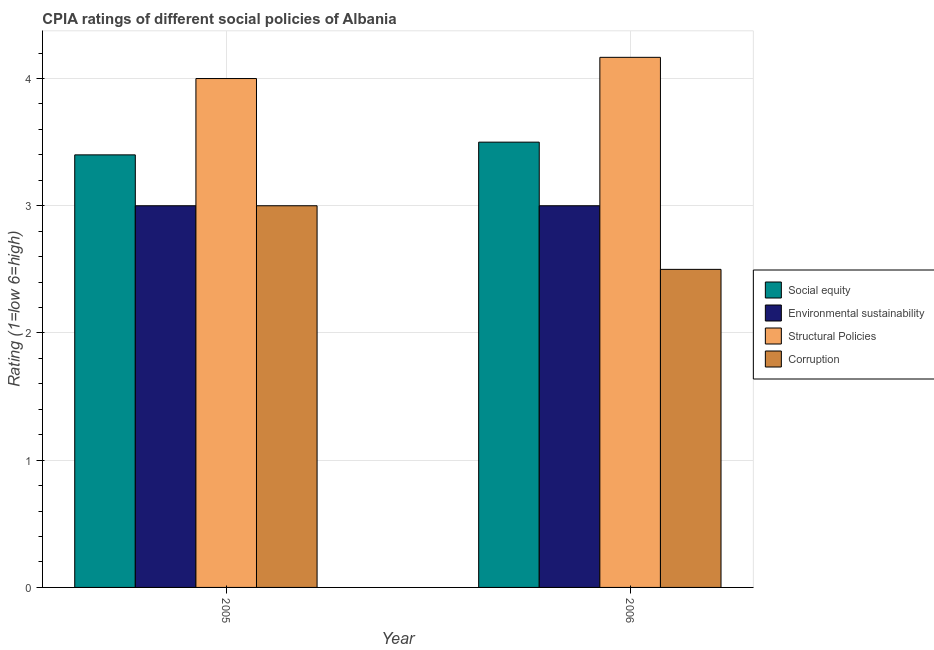How many different coloured bars are there?
Give a very brief answer. 4. Are the number of bars per tick equal to the number of legend labels?
Your response must be concise. Yes. Are the number of bars on each tick of the X-axis equal?
Give a very brief answer. Yes. How many bars are there on the 1st tick from the left?
Make the answer very short. 4. Across all years, what is the maximum cpia rating of environmental sustainability?
Provide a short and direct response. 3. Across all years, what is the minimum cpia rating of structural policies?
Keep it short and to the point. 4. In which year was the cpia rating of corruption maximum?
Ensure brevity in your answer.  2005. What is the total cpia rating of environmental sustainability in the graph?
Keep it short and to the point. 6. What is the difference between the cpia rating of corruption in 2005 and the cpia rating of structural policies in 2006?
Offer a very short reply. 0.5. What is the average cpia rating of environmental sustainability per year?
Your answer should be very brief. 3. Is the cpia rating of environmental sustainability in 2005 less than that in 2006?
Your response must be concise. No. What does the 3rd bar from the left in 2006 represents?
Offer a very short reply. Structural Policies. What does the 1st bar from the right in 2005 represents?
Offer a very short reply. Corruption. Are all the bars in the graph horizontal?
Your response must be concise. No. How many years are there in the graph?
Your response must be concise. 2. Are the values on the major ticks of Y-axis written in scientific E-notation?
Offer a terse response. No. How are the legend labels stacked?
Your response must be concise. Vertical. What is the title of the graph?
Your response must be concise. CPIA ratings of different social policies of Albania. Does "Mammal species" appear as one of the legend labels in the graph?
Ensure brevity in your answer.  No. What is the label or title of the X-axis?
Provide a short and direct response. Year. What is the label or title of the Y-axis?
Give a very brief answer. Rating (1=low 6=high). What is the Rating (1=low 6=high) of Corruption in 2005?
Give a very brief answer. 3. What is the Rating (1=low 6=high) in Social equity in 2006?
Make the answer very short. 3.5. What is the Rating (1=low 6=high) in Environmental sustainability in 2006?
Your response must be concise. 3. What is the Rating (1=low 6=high) of Structural Policies in 2006?
Provide a short and direct response. 4.17. Across all years, what is the maximum Rating (1=low 6=high) of Environmental sustainability?
Make the answer very short. 3. Across all years, what is the maximum Rating (1=low 6=high) of Structural Policies?
Keep it short and to the point. 4.17. Across all years, what is the maximum Rating (1=low 6=high) of Corruption?
Offer a very short reply. 3. Across all years, what is the minimum Rating (1=low 6=high) in Social equity?
Offer a terse response. 3.4. Across all years, what is the minimum Rating (1=low 6=high) in Corruption?
Provide a succinct answer. 2.5. What is the total Rating (1=low 6=high) in Social equity in the graph?
Provide a succinct answer. 6.9. What is the total Rating (1=low 6=high) in Structural Policies in the graph?
Provide a succinct answer. 8.17. What is the total Rating (1=low 6=high) of Corruption in the graph?
Keep it short and to the point. 5.5. What is the difference between the Rating (1=low 6=high) of Social equity in 2005 and that in 2006?
Your answer should be very brief. -0.1. What is the difference between the Rating (1=low 6=high) of Structural Policies in 2005 and that in 2006?
Offer a terse response. -0.17. What is the difference between the Rating (1=low 6=high) in Social equity in 2005 and the Rating (1=low 6=high) in Structural Policies in 2006?
Provide a succinct answer. -0.77. What is the difference between the Rating (1=low 6=high) in Environmental sustainability in 2005 and the Rating (1=low 6=high) in Structural Policies in 2006?
Make the answer very short. -1.17. What is the average Rating (1=low 6=high) of Social equity per year?
Offer a terse response. 3.45. What is the average Rating (1=low 6=high) in Environmental sustainability per year?
Offer a terse response. 3. What is the average Rating (1=low 6=high) of Structural Policies per year?
Keep it short and to the point. 4.08. What is the average Rating (1=low 6=high) of Corruption per year?
Provide a short and direct response. 2.75. In the year 2005, what is the difference between the Rating (1=low 6=high) in Social equity and Rating (1=low 6=high) in Environmental sustainability?
Make the answer very short. 0.4. In the year 2005, what is the difference between the Rating (1=low 6=high) in Social equity and Rating (1=low 6=high) in Structural Policies?
Provide a short and direct response. -0.6. In the year 2006, what is the difference between the Rating (1=low 6=high) of Social equity and Rating (1=low 6=high) of Corruption?
Provide a succinct answer. 1. In the year 2006, what is the difference between the Rating (1=low 6=high) of Environmental sustainability and Rating (1=low 6=high) of Structural Policies?
Offer a terse response. -1.17. What is the ratio of the Rating (1=low 6=high) of Social equity in 2005 to that in 2006?
Give a very brief answer. 0.97. What is the ratio of the Rating (1=low 6=high) in Environmental sustainability in 2005 to that in 2006?
Ensure brevity in your answer.  1. What is the difference between the highest and the second highest Rating (1=low 6=high) in Social equity?
Your response must be concise. 0.1. What is the difference between the highest and the second highest Rating (1=low 6=high) in Corruption?
Keep it short and to the point. 0.5. What is the difference between the highest and the lowest Rating (1=low 6=high) of Structural Policies?
Provide a succinct answer. 0.17. 